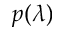Convert formula to latex. <formula><loc_0><loc_0><loc_500><loc_500>p ( \lambda )</formula> 